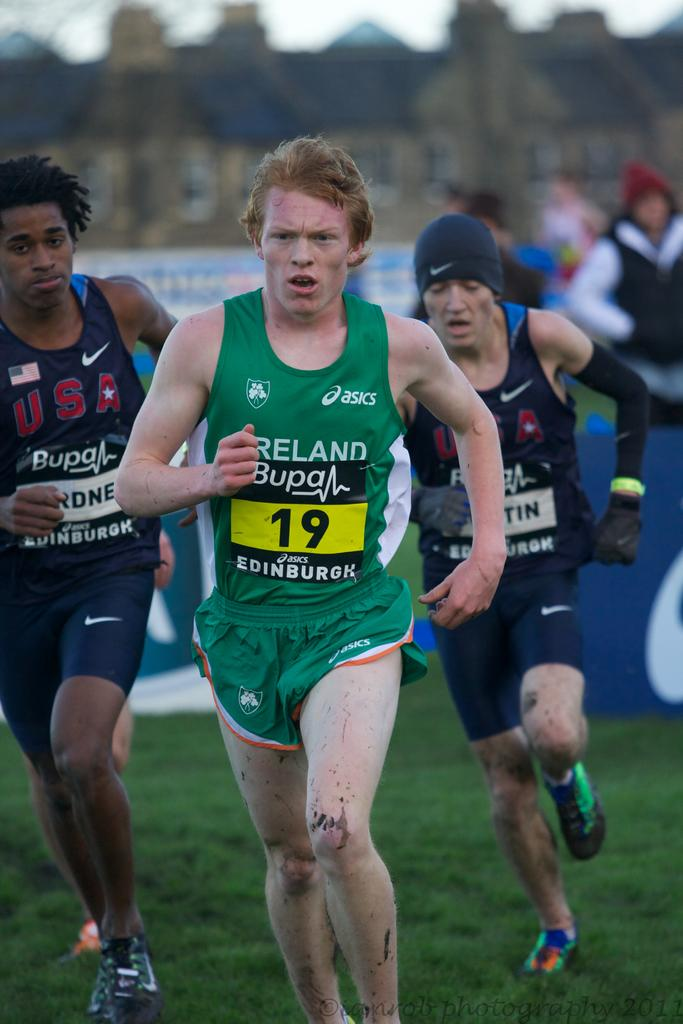<image>
Describe the image concisely. The irish runner in the race wears the number 19 on his bib. 